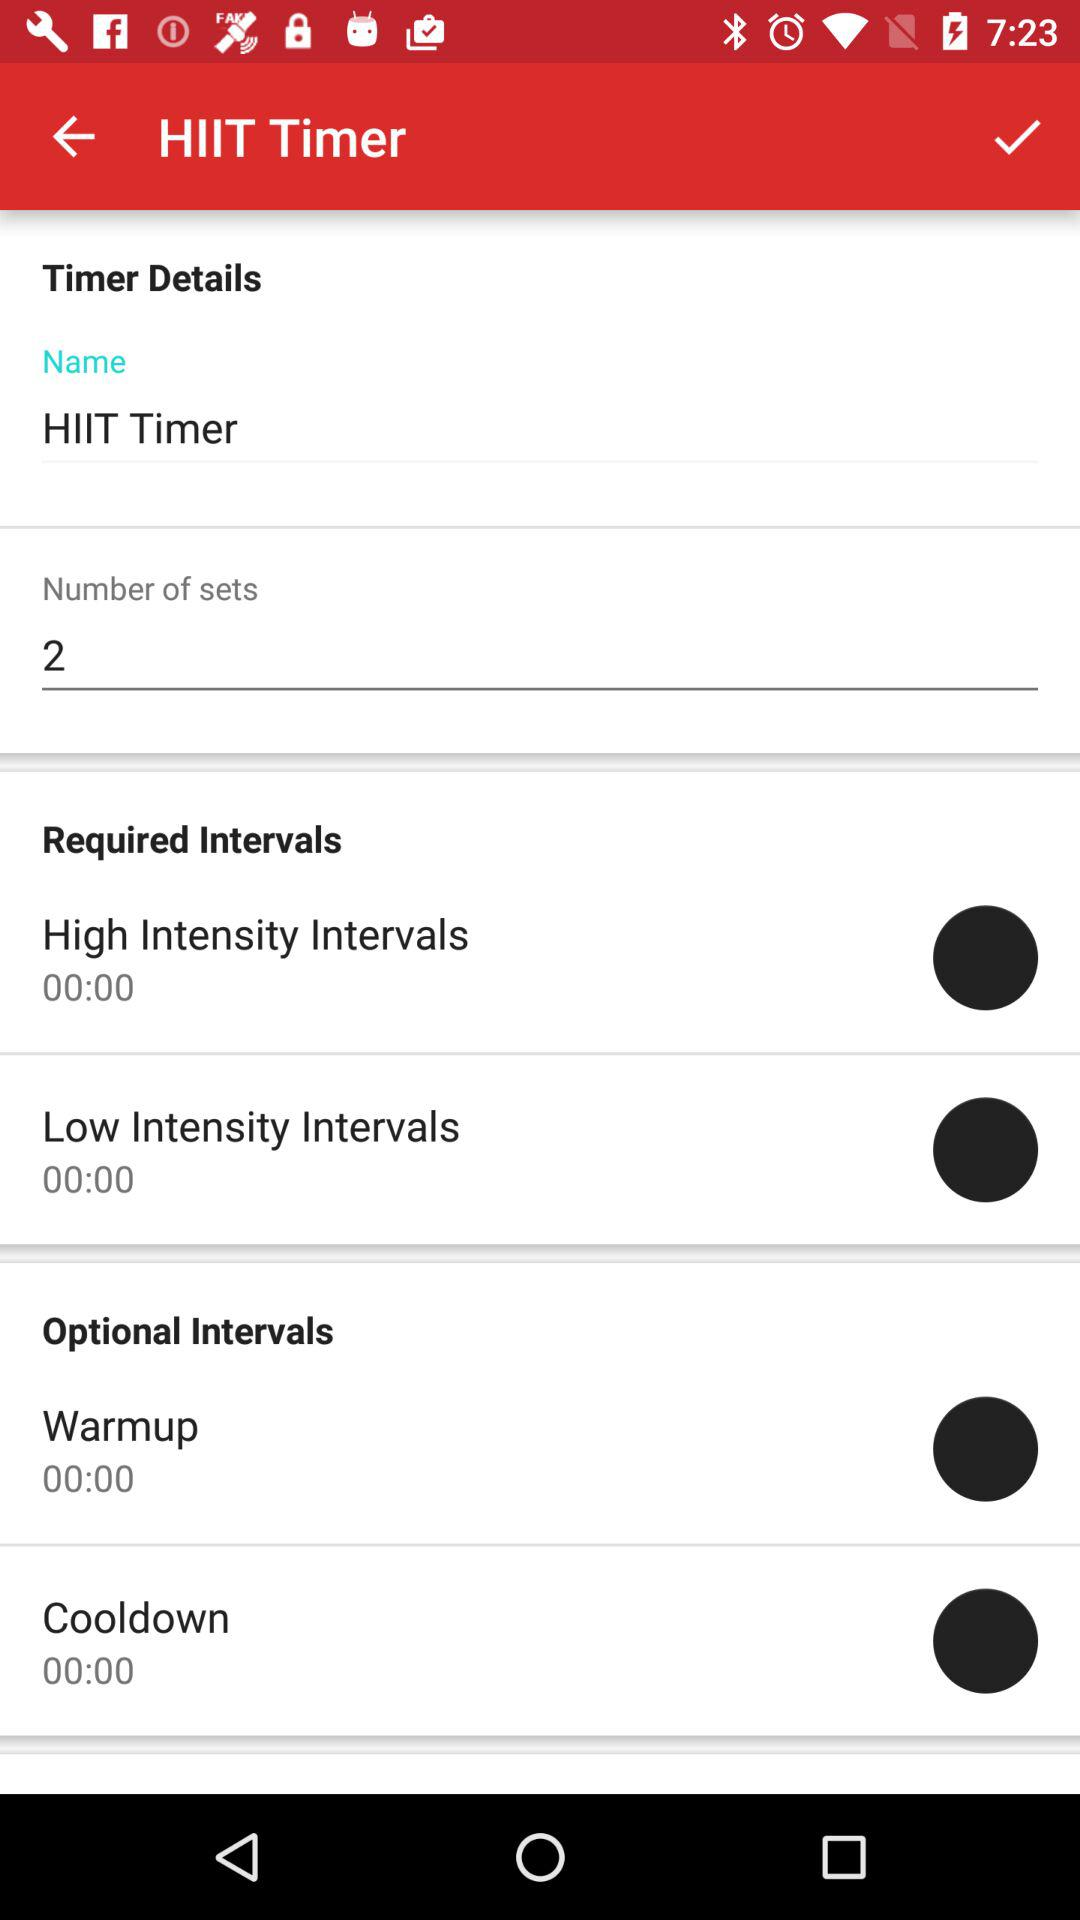What are the options given in "Optional Intervals"? The options are "Warmup" and "Cooldown". 